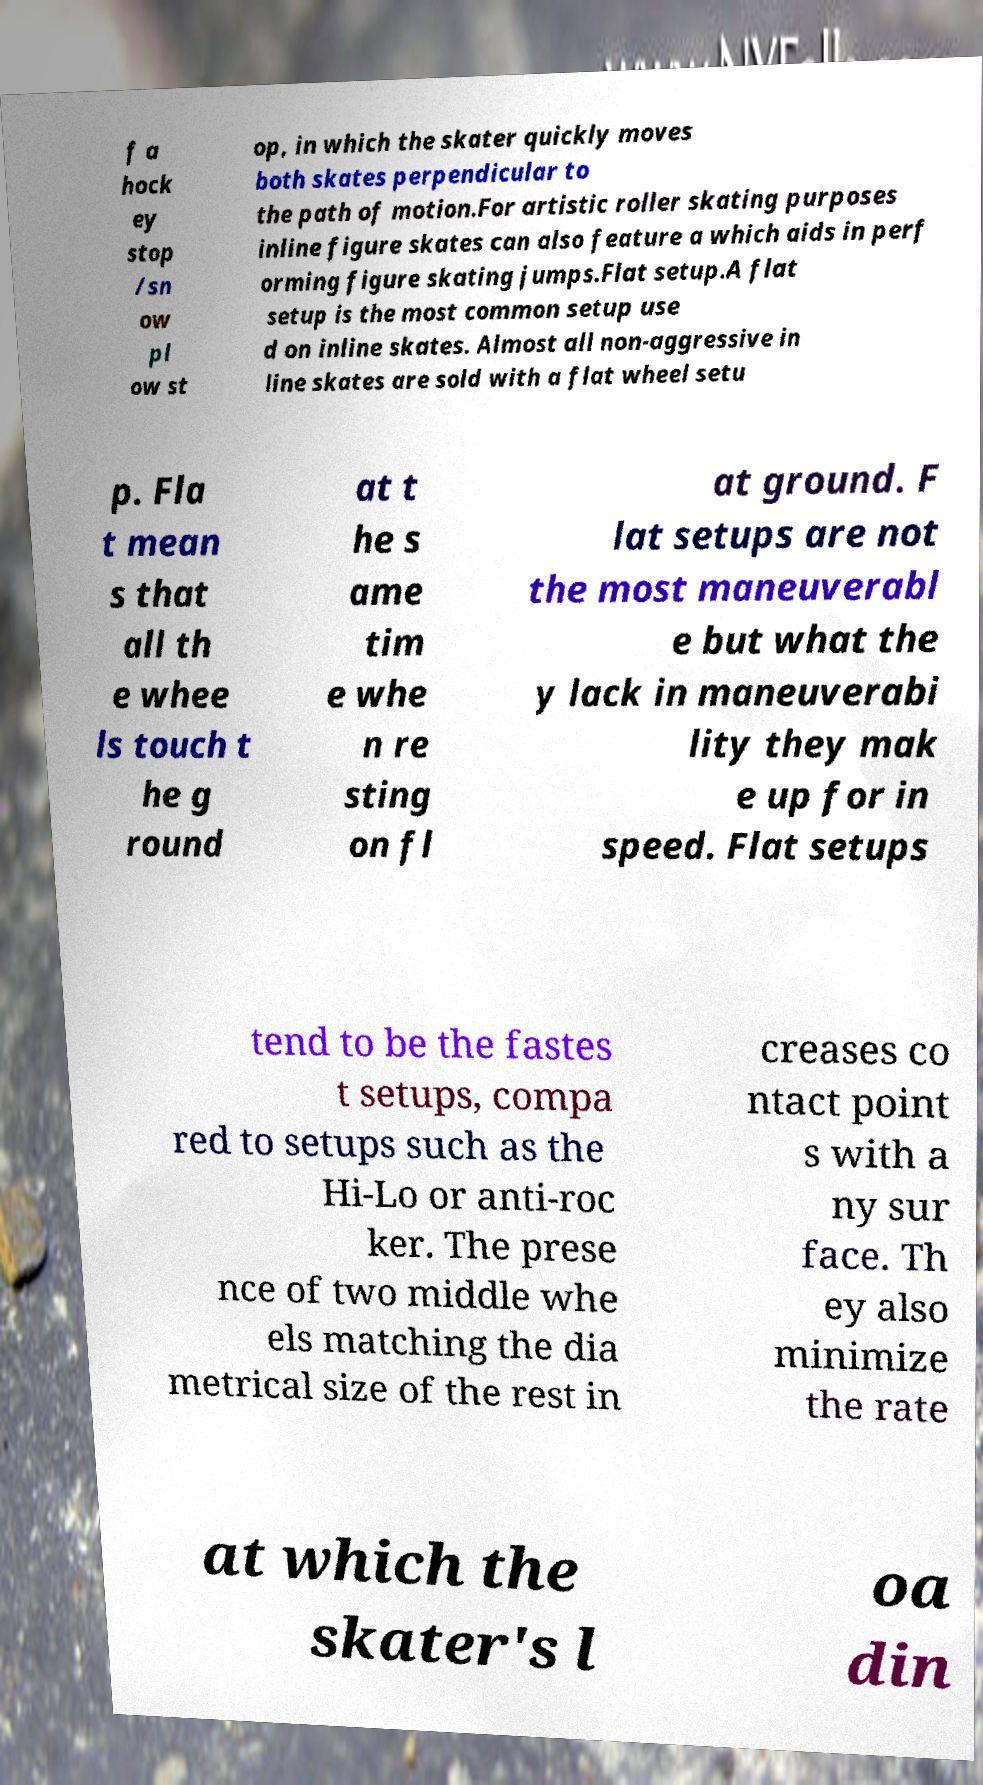What messages or text are displayed in this image? I need them in a readable, typed format. f a hock ey stop /sn ow pl ow st op, in which the skater quickly moves both skates perpendicular to the path of motion.For artistic roller skating purposes inline figure skates can also feature a which aids in perf orming figure skating jumps.Flat setup.A flat setup is the most common setup use d on inline skates. Almost all non-aggressive in line skates are sold with a flat wheel setu p. Fla t mean s that all th e whee ls touch t he g round at t he s ame tim e whe n re sting on fl at ground. F lat setups are not the most maneuverabl e but what the y lack in maneuverabi lity they mak e up for in speed. Flat setups tend to be the fastes t setups, compa red to setups such as the Hi-Lo or anti-roc ker. The prese nce of two middle whe els matching the dia metrical size of the rest in creases co ntact point s with a ny sur face. Th ey also minimize the rate at which the skater's l oa din 